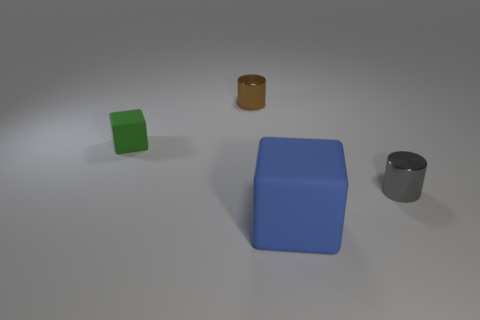Add 2 green matte blocks. How many objects exist? 6 Subtract 2 blocks. How many blocks are left? 0 Subtract all green cubes. How many cubes are left? 1 Subtract all tiny brown metal things. Subtract all tiny cylinders. How many objects are left? 1 Add 2 green rubber cubes. How many green rubber cubes are left? 3 Add 4 green metal cylinders. How many green metal cylinders exist? 4 Subtract 0 cyan balls. How many objects are left? 4 Subtract all blue cylinders. Subtract all green balls. How many cylinders are left? 2 Subtract all gray cylinders. How many purple blocks are left? 0 